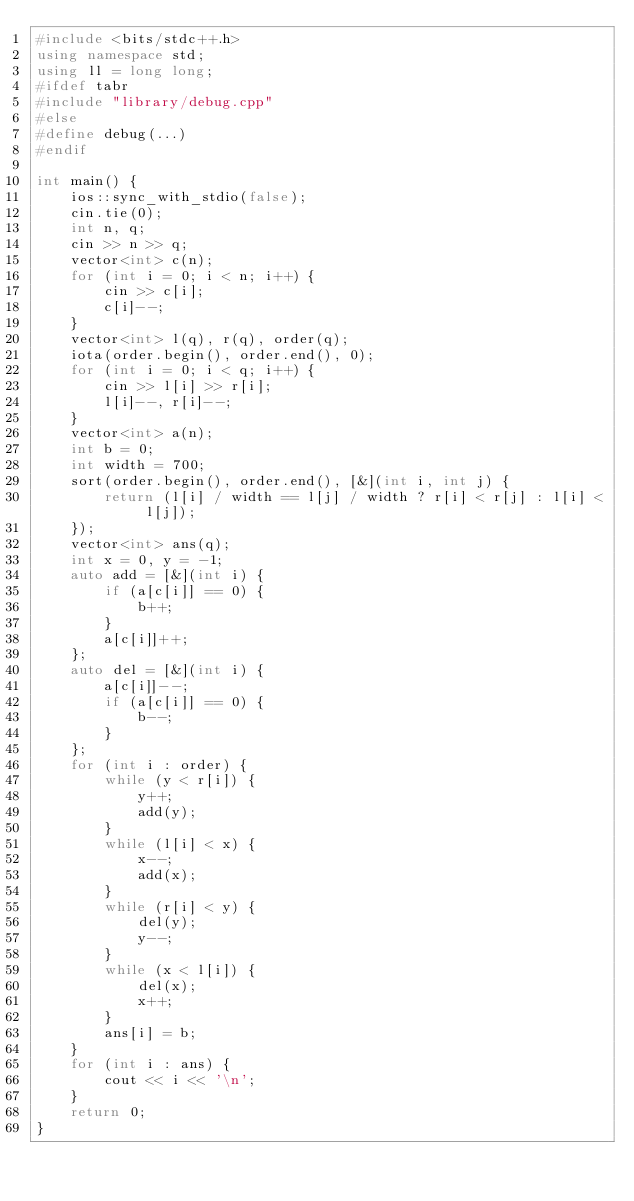Convert code to text. <code><loc_0><loc_0><loc_500><loc_500><_C++_>#include <bits/stdc++.h>
using namespace std;
using ll = long long;
#ifdef tabr
#include "library/debug.cpp"
#else
#define debug(...)
#endif

int main() {
    ios::sync_with_stdio(false);
    cin.tie(0);
    int n, q;
    cin >> n >> q;
    vector<int> c(n);
    for (int i = 0; i < n; i++) {
        cin >> c[i];
        c[i]--;
    }
    vector<int> l(q), r(q), order(q);
    iota(order.begin(), order.end(), 0);
    for (int i = 0; i < q; i++) {
        cin >> l[i] >> r[i];
        l[i]--, r[i]--;
    }
    vector<int> a(n);
    int b = 0;
    int width = 700;
    sort(order.begin(), order.end(), [&](int i, int j) {
        return (l[i] / width == l[j] / width ? r[i] < r[j] : l[i] < l[j]);
    });
    vector<int> ans(q);
    int x = 0, y = -1;
    auto add = [&](int i) {
        if (a[c[i]] == 0) {
            b++;
        }
        a[c[i]]++;
    };
    auto del = [&](int i) {
        a[c[i]]--;
        if (a[c[i]] == 0) {
            b--;
        }
    };
    for (int i : order) {
        while (y < r[i]) {
            y++;
            add(y);
        }
        while (l[i] < x) {
            x--;
            add(x);
        }
        while (r[i] < y) {
            del(y);
            y--;
        }
        while (x < l[i]) {
            del(x);
            x++;
        }
        ans[i] = b;
    }
    for (int i : ans) {
        cout << i << '\n';
    }
    return 0;
}</code> 